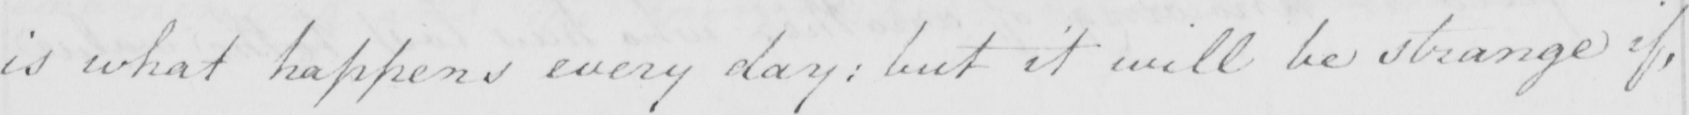Please provide the text content of this handwritten line. is what happens every day :  but it will be strange if , 